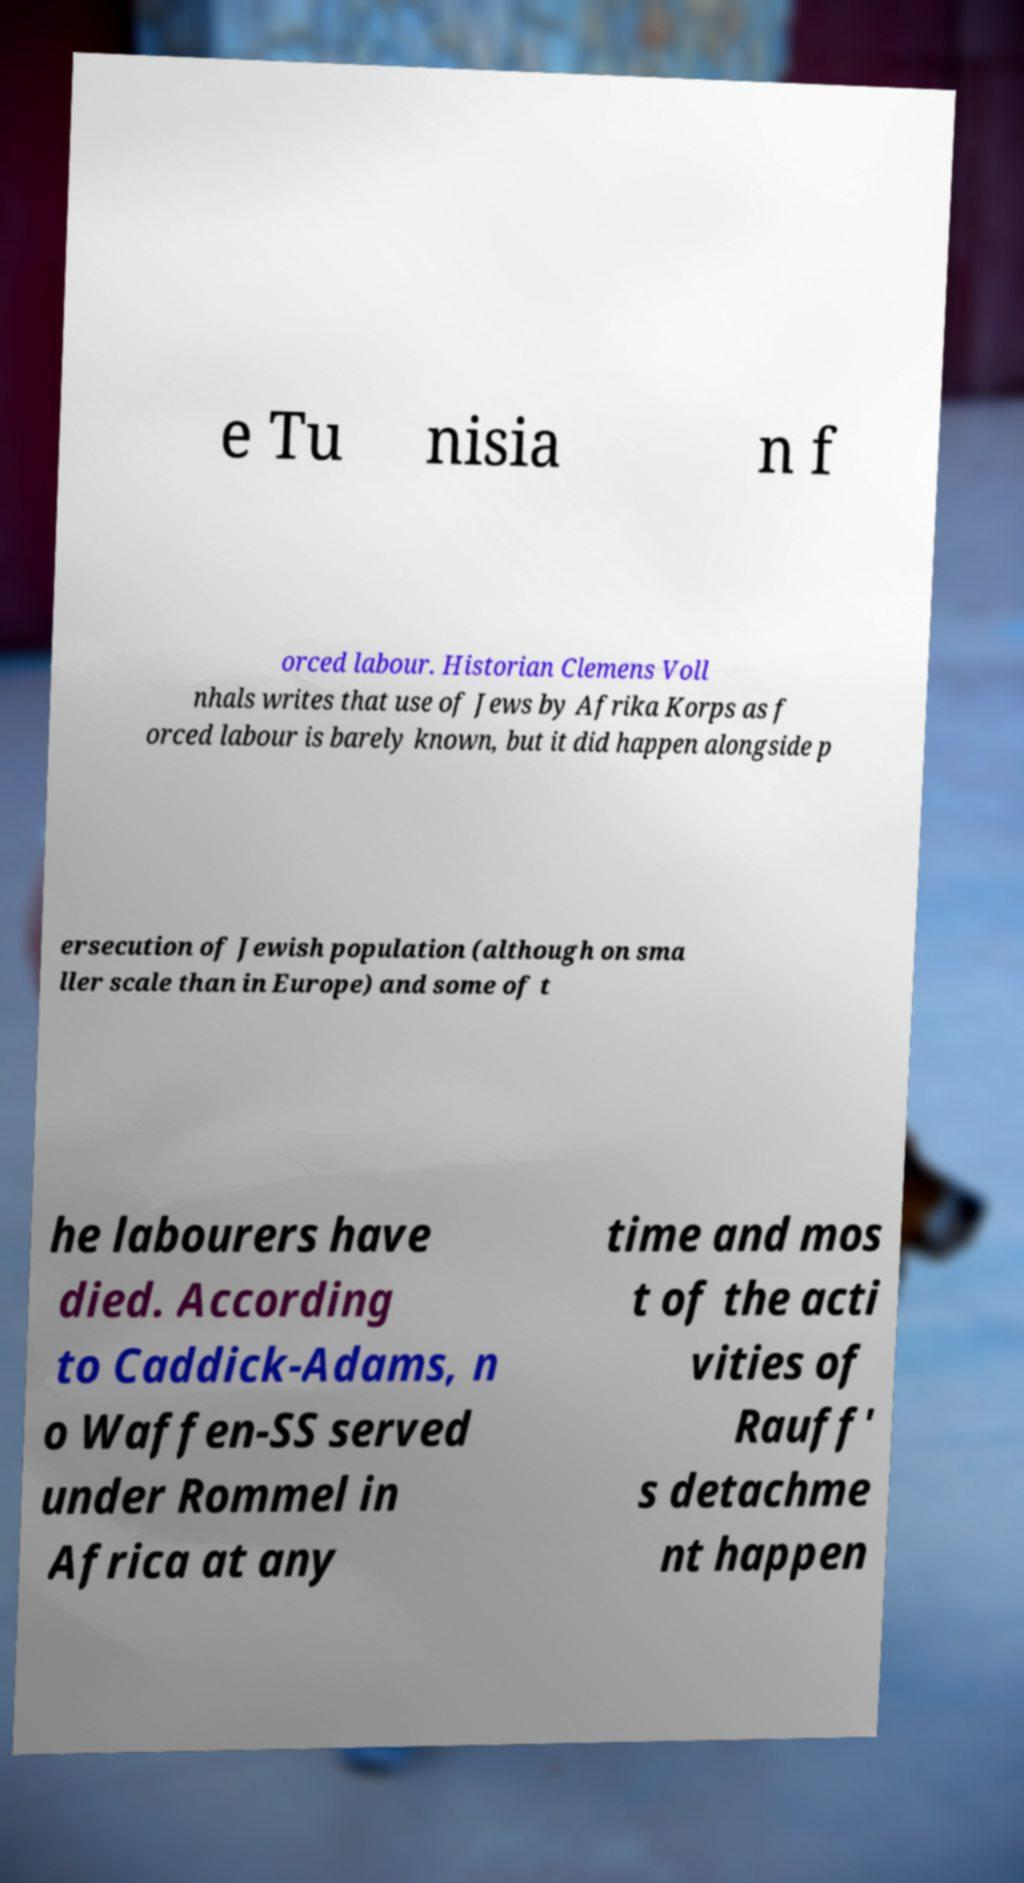Can you accurately transcribe the text from the provided image for me? e Tu nisia n f orced labour. Historian Clemens Voll nhals writes that use of Jews by Afrika Korps as f orced labour is barely known, but it did happen alongside p ersecution of Jewish population (although on sma ller scale than in Europe) and some of t he labourers have died. According to Caddick-Adams, n o Waffen-SS served under Rommel in Africa at any time and mos t of the acti vities of Rauff' s detachme nt happen 